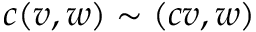<formula> <loc_0><loc_0><loc_500><loc_500>c ( v , w ) \sim ( c v , w )</formula> 